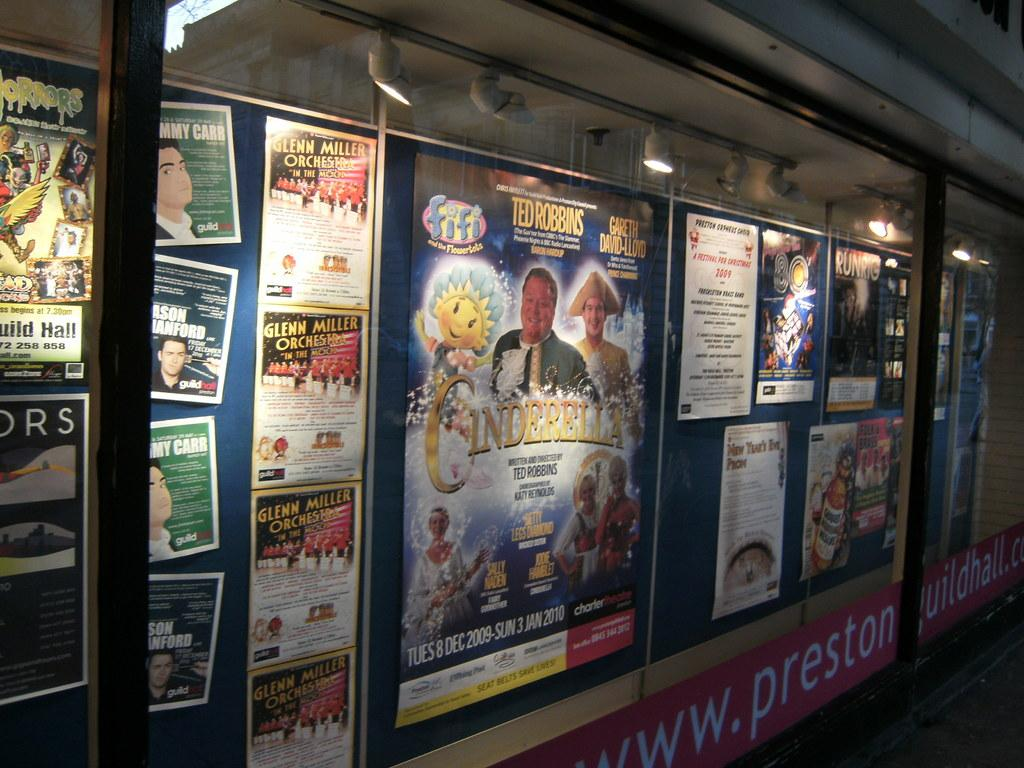What is present on the wall in the image? There are posters on the wall in the image. Can you describe the lights visible at the top of the image? Unfortunately, the provided facts do not give any information about the lights, so we cannot describe them. What is the primary feature of the wall in the image? The primary feature of the wall in the image is the presence of posters. How many eyes can be seen on the posters in the image? There is no information about eyes on the posters in the provided facts, so we cannot determine the number of eyes. What industry is represented by the posters in the image? There is no information about the industry represented by the posters in the provided facts, so we cannot determine the industry. 